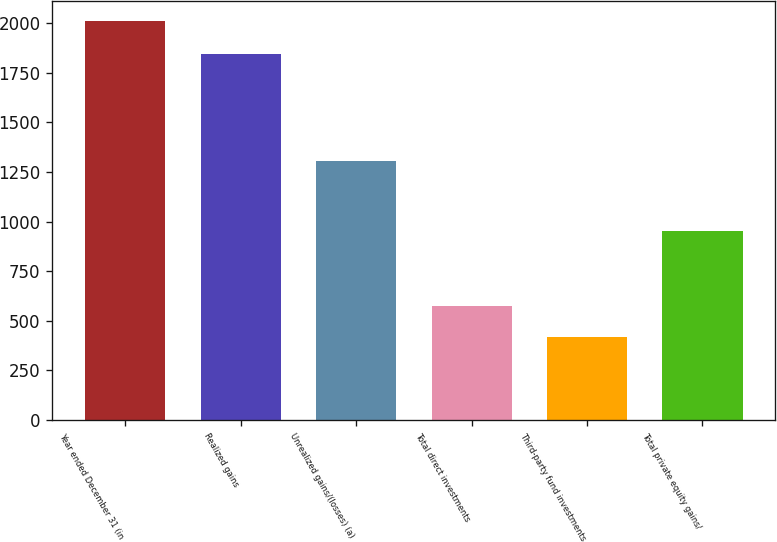Convert chart to OTSL. <chart><loc_0><loc_0><loc_500><loc_500><bar_chart><fcel>Year ended December 31 (in<fcel>Realized gains<fcel>Unrealized gains/(losses) (a)<fcel>Total direct investments<fcel>Third-party fund investments<fcel>Total private equity gains/<nl><fcel>2011<fcel>1842<fcel>1305<fcel>576.4<fcel>417<fcel>954<nl></chart> 